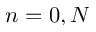<formula> <loc_0><loc_0><loc_500><loc_500>n = 0 , N</formula> 